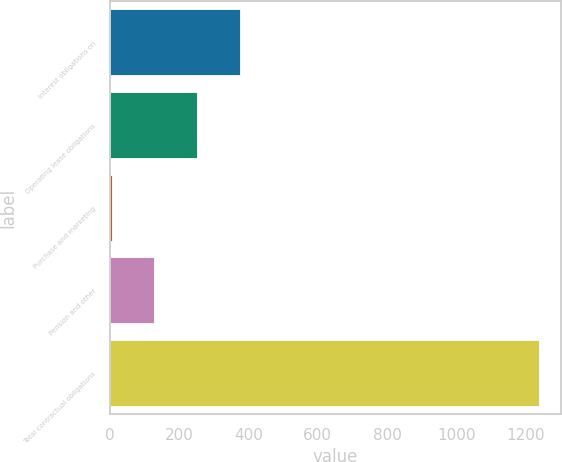Convert chart to OTSL. <chart><loc_0><loc_0><loc_500><loc_500><bar_chart><fcel>Interest obligations on<fcel>Operating lease obligations<fcel>Purchase and marketing<fcel>Pension and other<fcel>Total contractual obligations<nl><fcel>374.82<fcel>251.18<fcel>3.9<fcel>127.54<fcel>1240.3<nl></chart> 